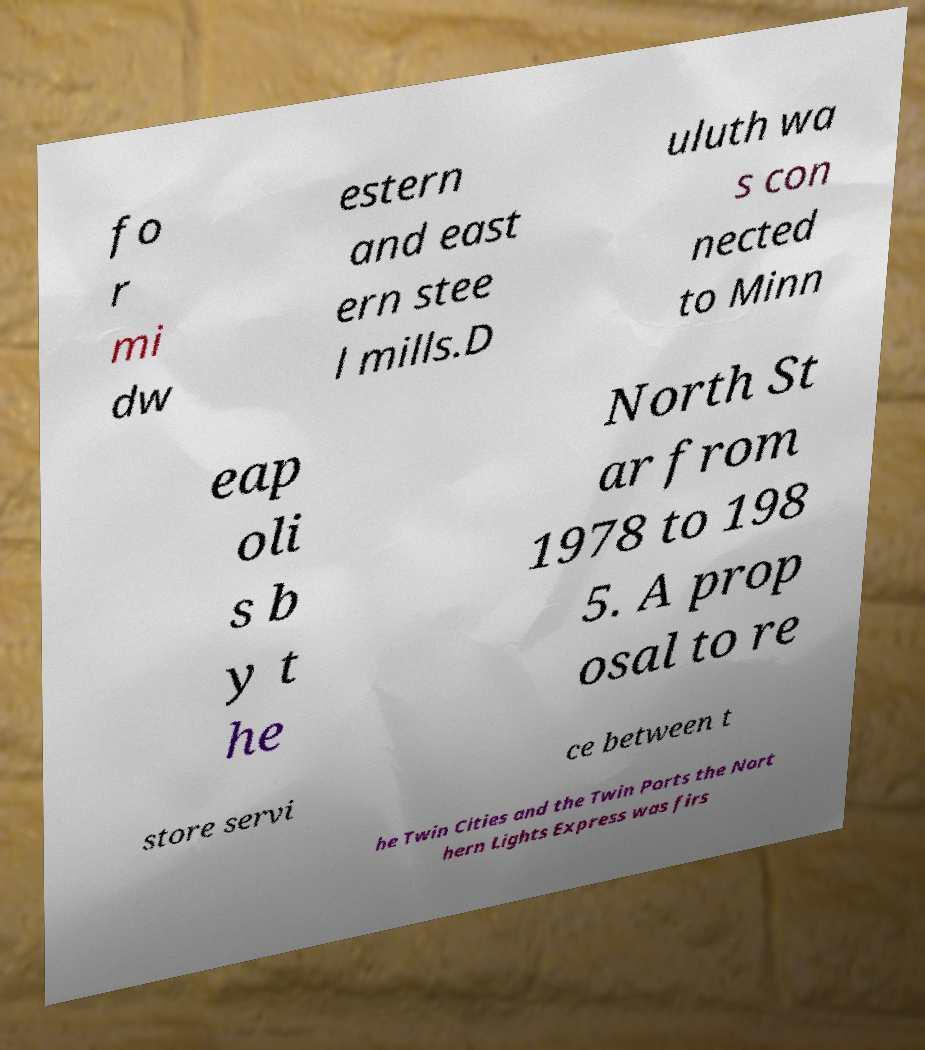What messages or text are displayed in this image? I need them in a readable, typed format. fo r mi dw estern and east ern stee l mills.D uluth wa s con nected to Minn eap oli s b y t he North St ar from 1978 to 198 5. A prop osal to re store servi ce between t he Twin Cities and the Twin Ports the Nort hern Lights Express was firs 